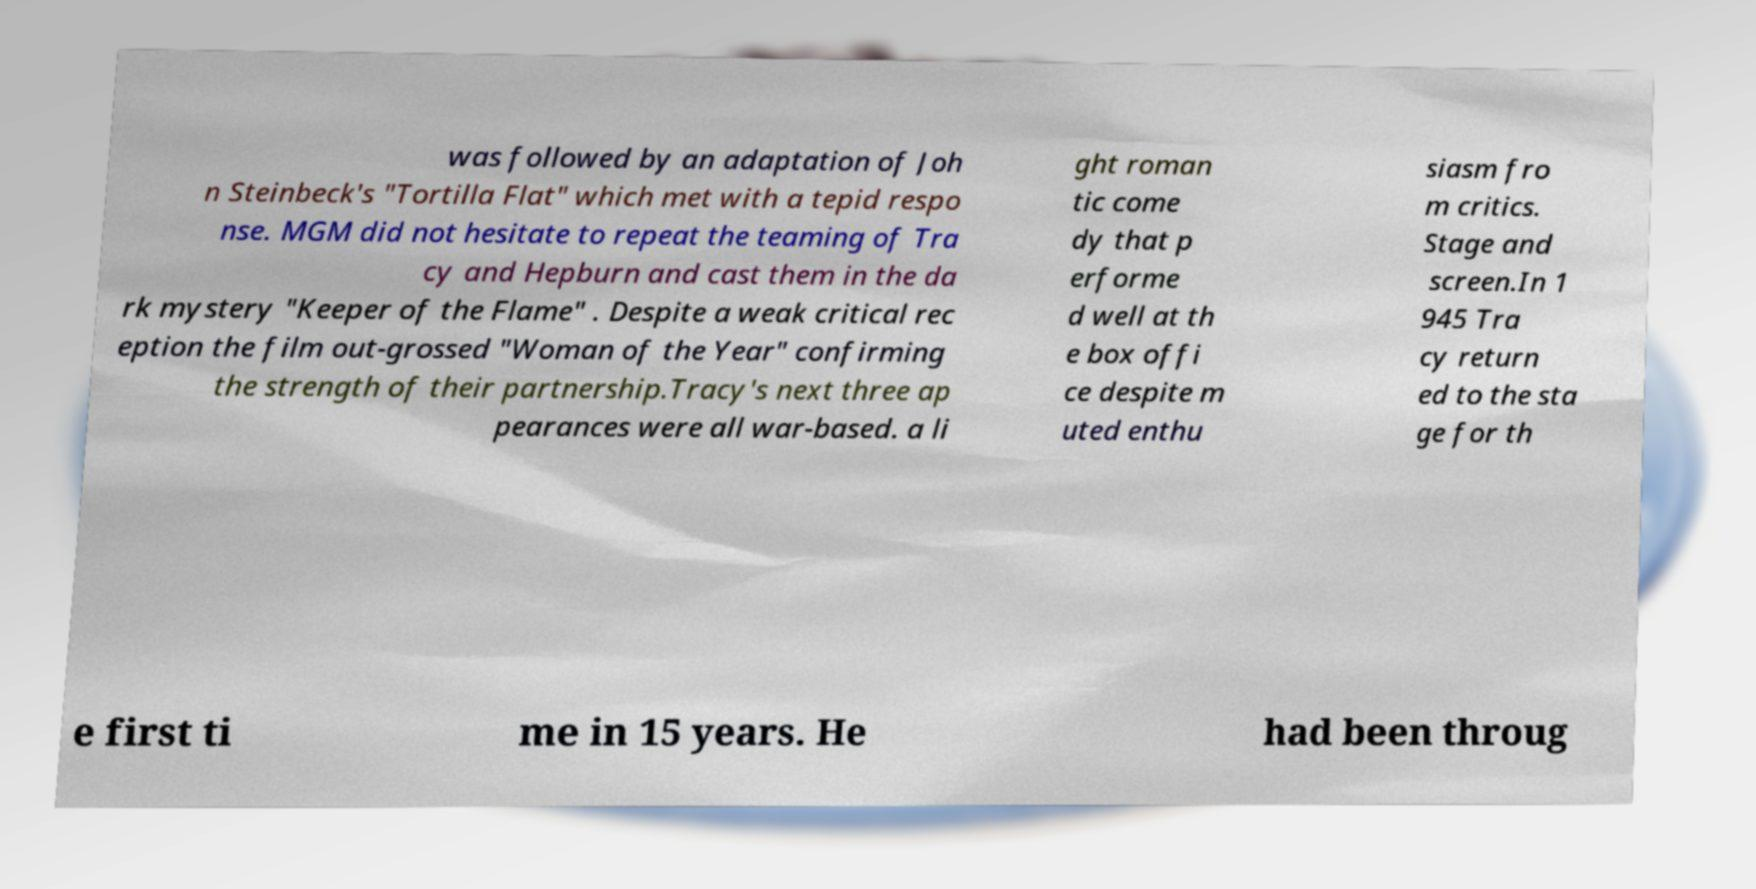Please read and relay the text visible in this image. What does it say? was followed by an adaptation of Joh n Steinbeck's "Tortilla Flat" which met with a tepid respo nse. MGM did not hesitate to repeat the teaming of Tra cy and Hepburn and cast them in the da rk mystery "Keeper of the Flame" . Despite a weak critical rec eption the film out-grossed "Woman of the Year" confirming the strength of their partnership.Tracy's next three ap pearances were all war-based. a li ght roman tic come dy that p erforme d well at th e box offi ce despite m uted enthu siasm fro m critics. Stage and screen.In 1 945 Tra cy return ed to the sta ge for th e first ti me in 15 years. He had been throug 